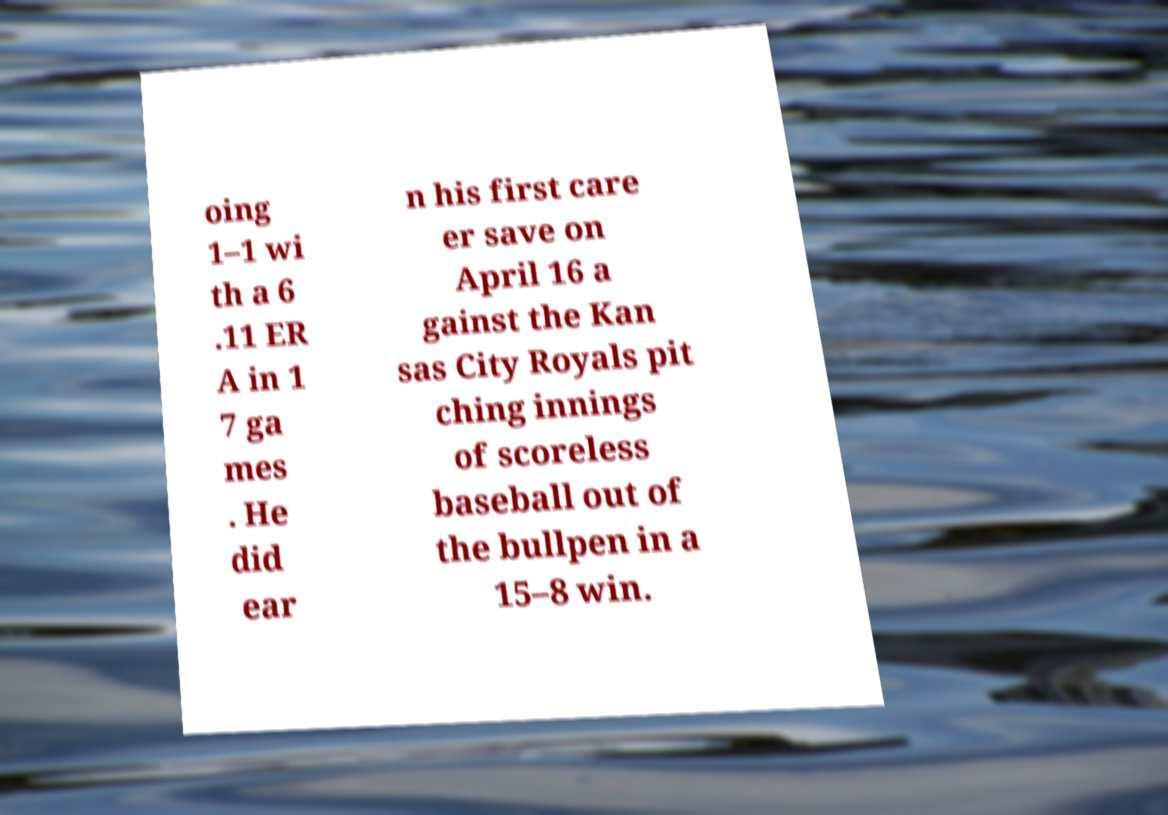Please identify and transcribe the text found in this image. oing 1–1 wi th a 6 .11 ER A in 1 7 ga mes . He did ear n his first care er save on April 16 a gainst the Kan sas City Royals pit ching innings of scoreless baseball out of the bullpen in a 15–8 win. 